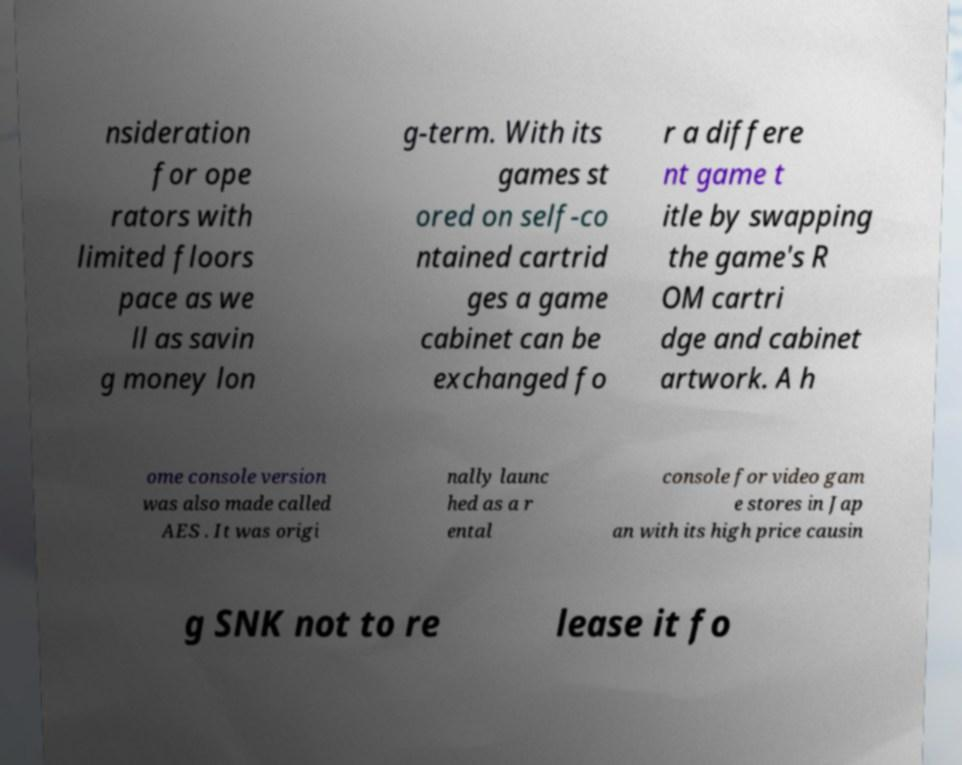There's text embedded in this image that I need extracted. Can you transcribe it verbatim? nsideration for ope rators with limited floors pace as we ll as savin g money lon g-term. With its games st ored on self-co ntained cartrid ges a game cabinet can be exchanged fo r a differe nt game t itle by swapping the game's R OM cartri dge and cabinet artwork. A h ome console version was also made called AES . It was origi nally launc hed as a r ental console for video gam e stores in Jap an with its high price causin g SNK not to re lease it fo 